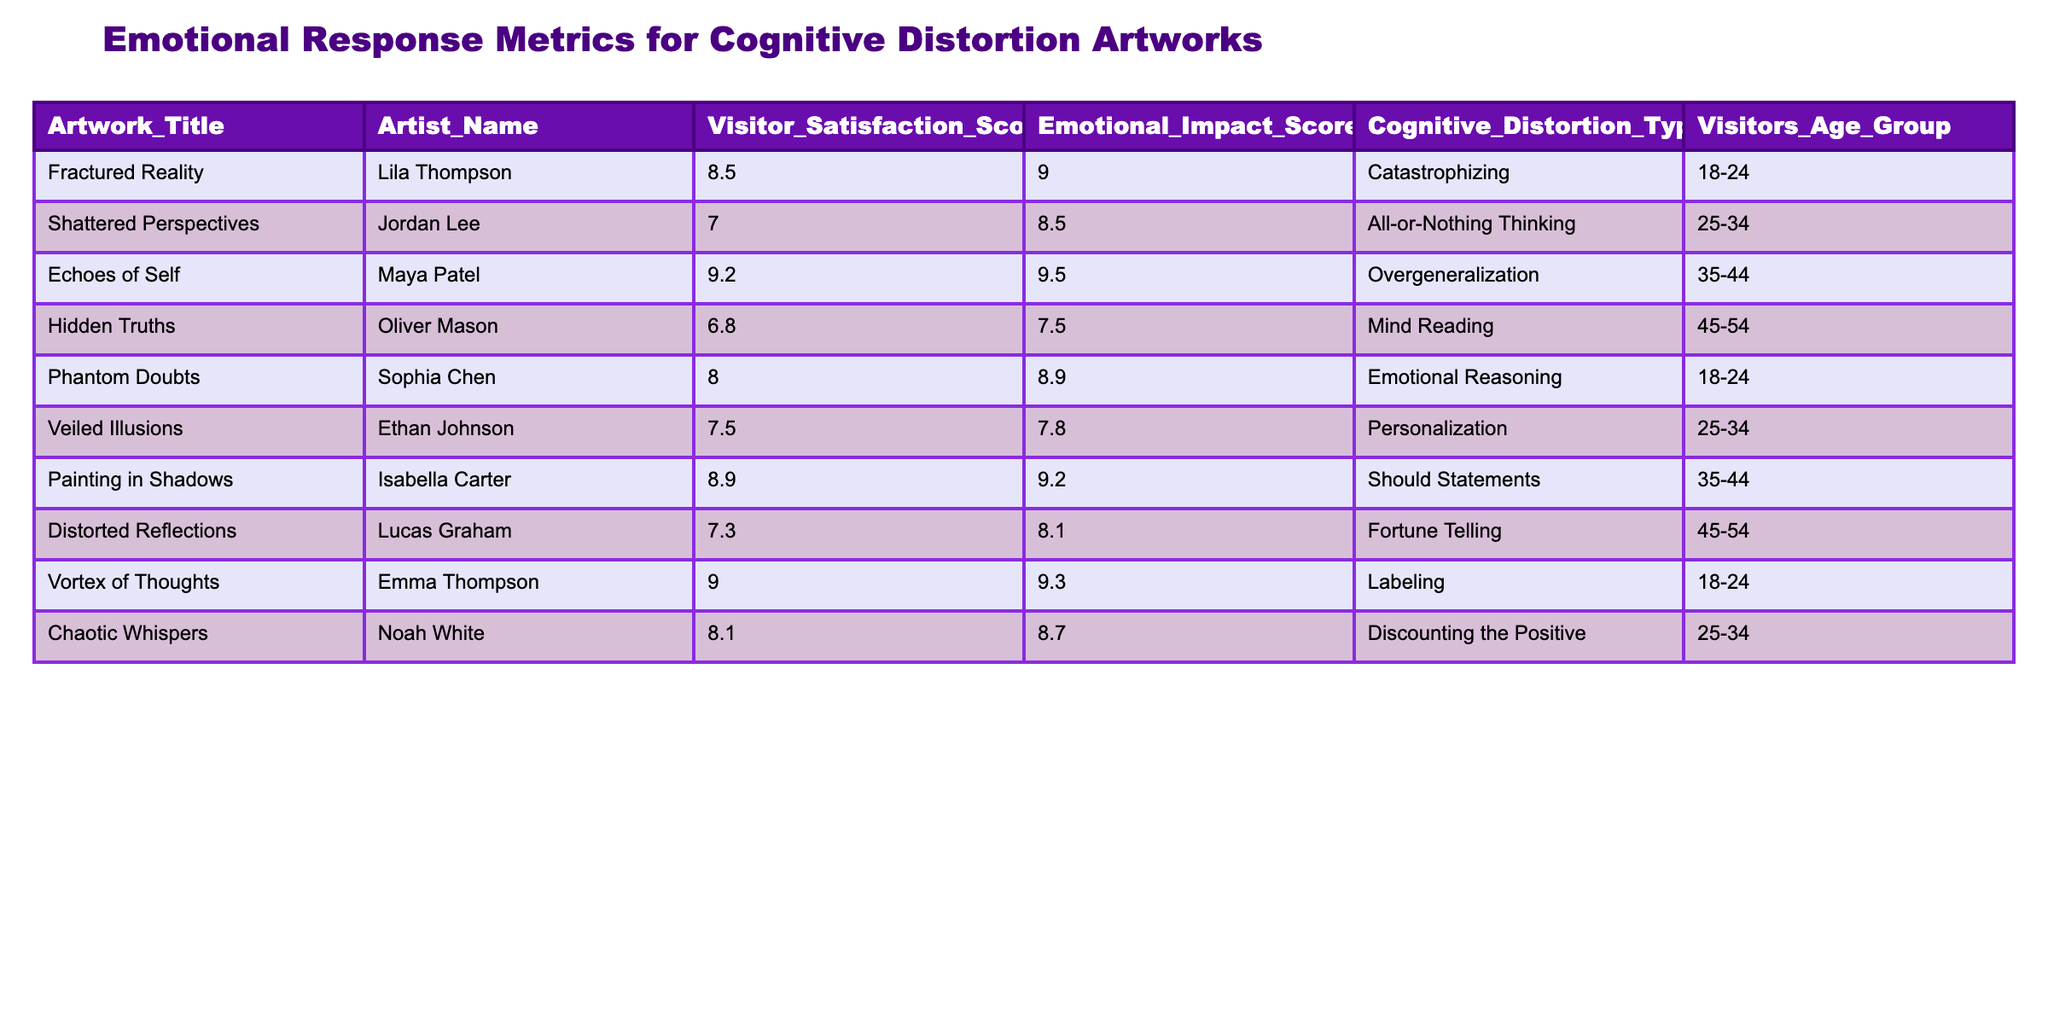What is the highest Visitor Satisfaction Score among the artworks? By examining the Visitor Satisfaction Scores in the table, I can identify the highest score, which is 9.2 attributed to the artwork "Echoes of Self" by Maya Patel.
Answer: 9.2 Which emotional impact score corresponds to the artwork "Phantom Doubts"? Looking at the Emotional Impact Score column for the artwork "Phantom Doubts," it shows a score of 8.9.
Answer: 8.9 Is there an artwork by an artist in the age group of 25-34 that received a satisfaction score above 8.0? Analyzing the age group column for 25-34, "Chaotic Whispers" scored 8.1, which is above 8.0, thus confirming the presence of such an artwork in that age group.
Answer: Yes What is the average Emotional Impact Score for artworks categorized under "All-or-Nothing Thinking" and "Should Statements"? First, I locate the Emotional Impact Scores for these categories: "Shattered Perspectives" (8.5) and "Painting in Shadows" (9.2). Adding these together gives 8.5 + 9.2 = 17.7. Dividing by the number of artworks (2) gives an average score of 17.7 / 2 = 8.85.
Answer: 8.85 How many artworks have a Visitor Satisfaction Score below 8.0? By scanning the Visitor Satisfaction Score column, I find "Shattered Perspectives" (7.0), "Hidden Truths" (6.8), and "Distorted Reflections" (7.3). This totals 3 artworks.
Answer: 3 